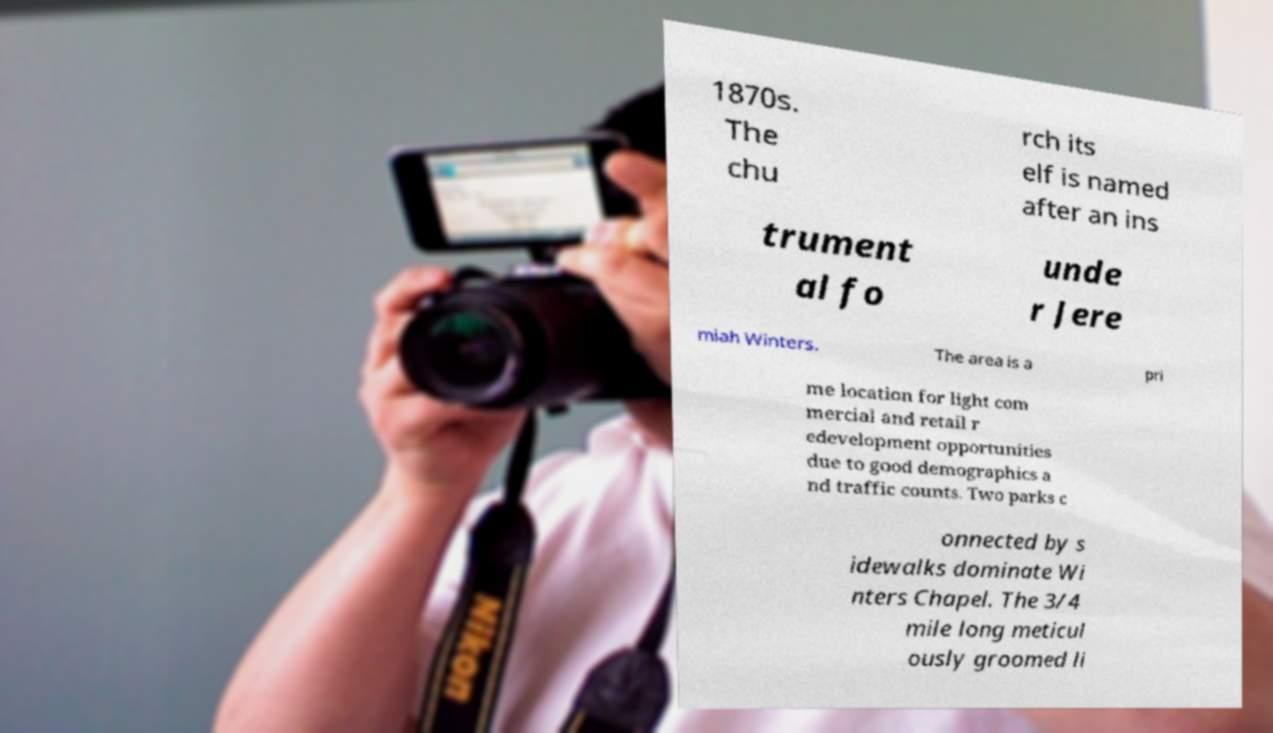Could you assist in decoding the text presented in this image and type it out clearly? 1870s. The chu rch its elf is named after an ins trument al fo unde r Jere miah Winters. The area is a pri me location for light com mercial and retail r edevelopment opportunities due to good demographics a nd traffic counts. Two parks c onnected by s idewalks dominate Wi nters Chapel. The 3/4 mile long meticul ously groomed li 